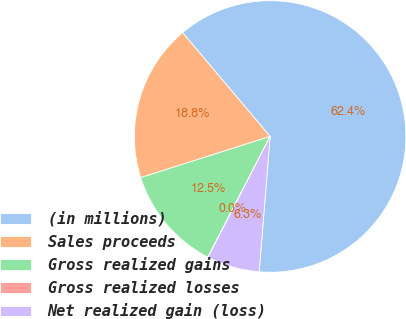Convert chart to OTSL. <chart><loc_0><loc_0><loc_500><loc_500><pie_chart><fcel>(in millions)<fcel>Sales proceeds<fcel>Gross realized gains<fcel>Gross realized losses<fcel>Net realized gain (loss)<nl><fcel>62.43%<fcel>18.75%<fcel>12.51%<fcel>0.03%<fcel>6.27%<nl></chart> 